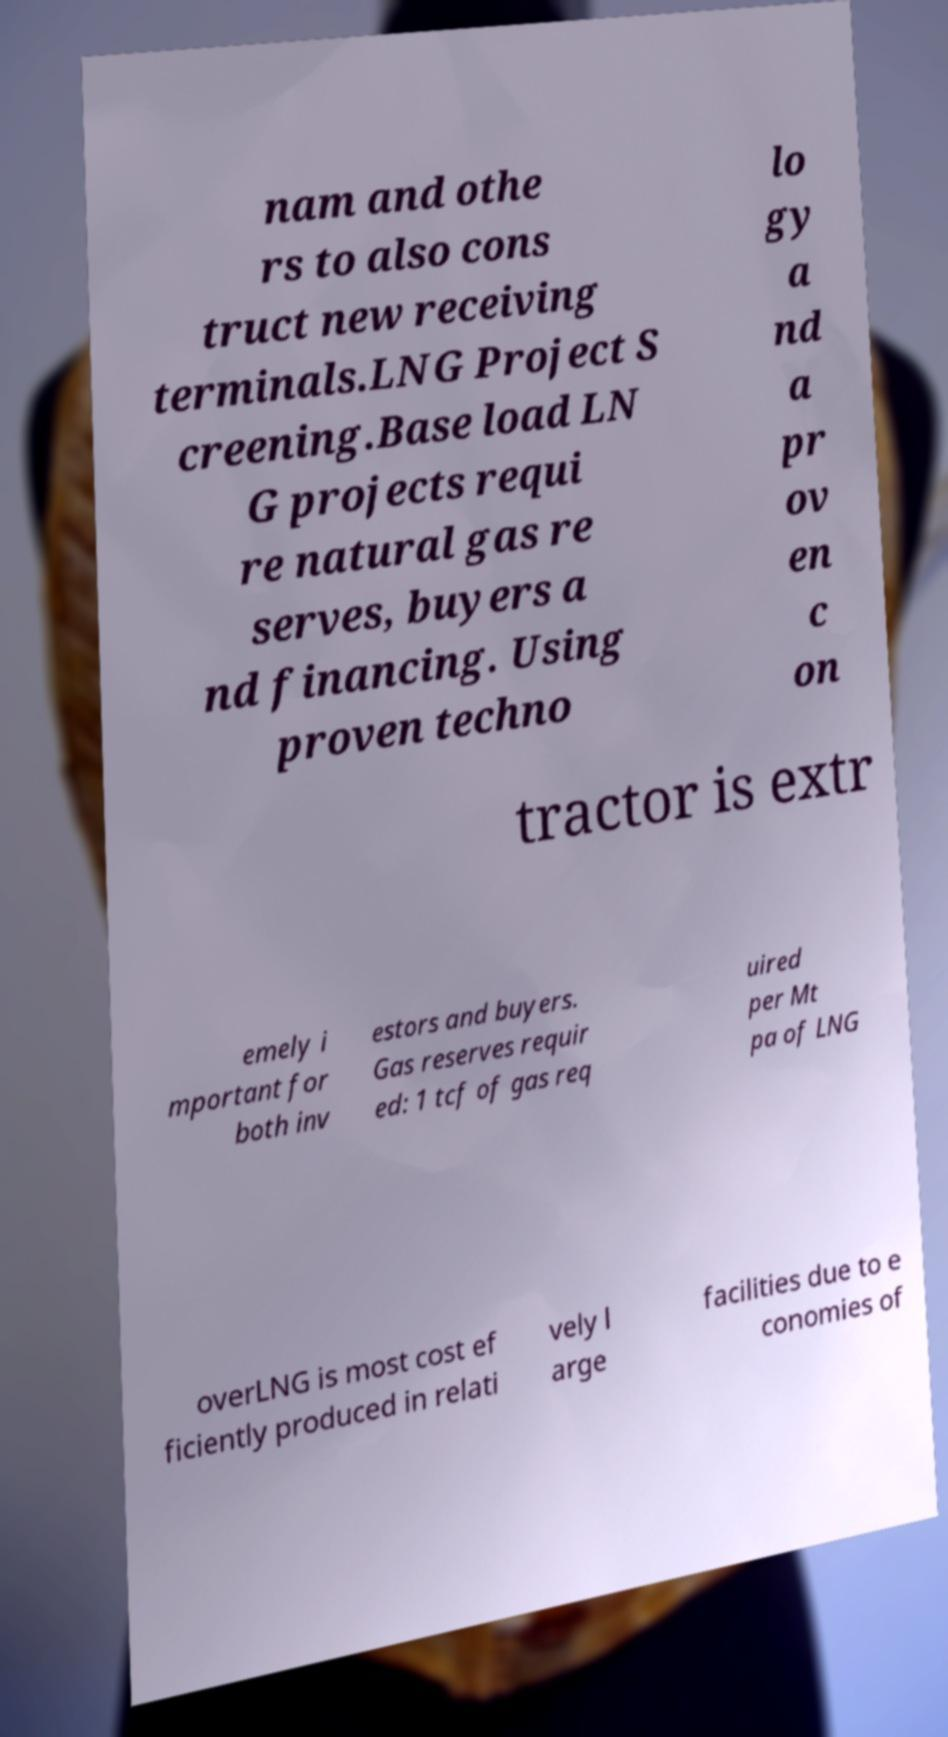What messages or text are displayed in this image? I need them in a readable, typed format. nam and othe rs to also cons truct new receiving terminals.LNG Project S creening.Base load LN G projects requi re natural gas re serves, buyers a nd financing. Using proven techno lo gy a nd a pr ov en c on tractor is extr emely i mportant for both inv estors and buyers. Gas reserves requir ed: 1 tcf of gas req uired per Mt pa of LNG overLNG is most cost ef ficiently produced in relati vely l arge facilities due to e conomies of 